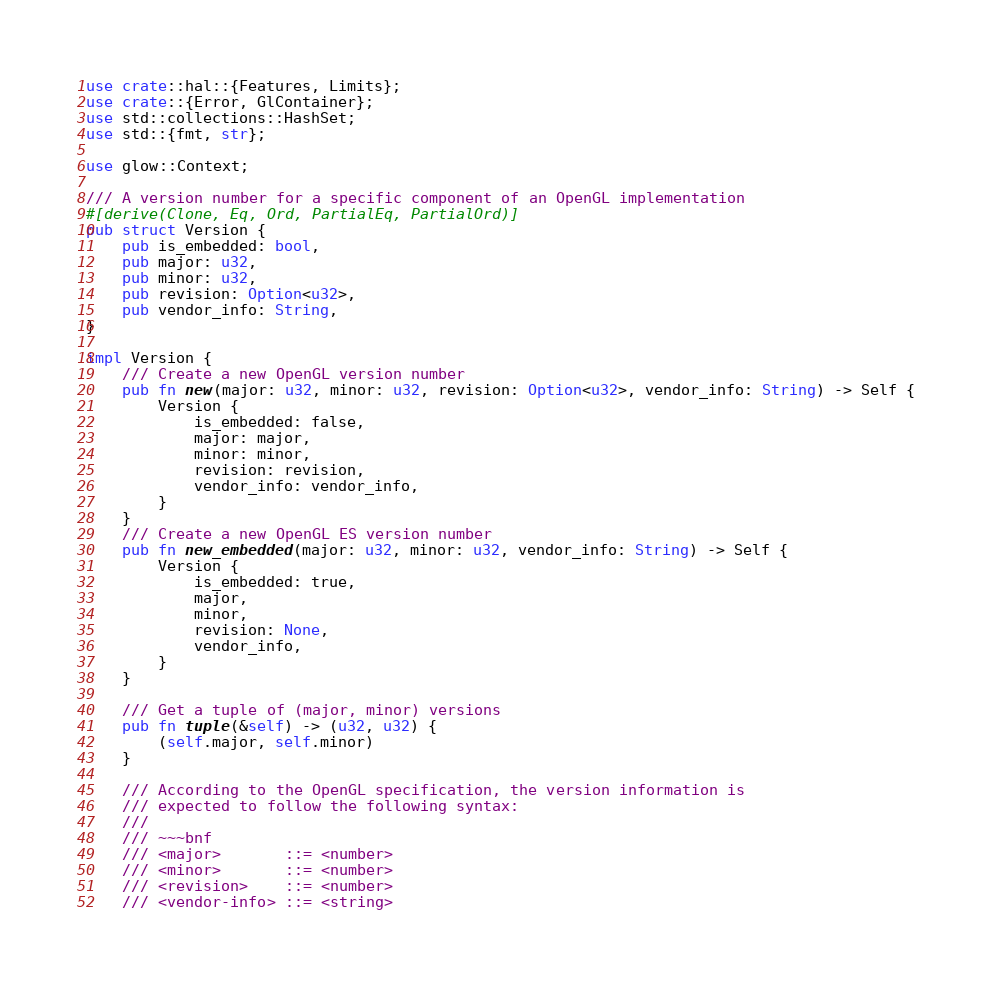Convert code to text. <code><loc_0><loc_0><loc_500><loc_500><_Rust_>use crate::hal::{Features, Limits};
use crate::{Error, GlContainer};
use std::collections::HashSet;
use std::{fmt, str};

use glow::Context;

/// A version number for a specific component of an OpenGL implementation
#[derive(Clone, Eq, Ord, PartialEq, PartialOrd)]
pub struct Version {
    pub is_embedded: bool,
    pub major: u32,
    pub minor: u32,
    pub revision: Option<u32>,
    pub vendor_info: String,
}

impl Version {
    /// Create a new OpenGL version number
    pub fn new(major: u32, minor: u32, revision: Option<u32>, vendor_info: String) -> Self {
        Version {
            is_embedded: false,
            major: major,
            minor: minor,
            revision: revision,
            vendor_info: vendor_info,
        }
    }
    /// Create a new OpenGL ES version number
    pub fn new_embedded(major: u32, minor: u32, vendor_info: String) -> Self {
        Version {
            is_embedded: true,
            major,
            minor,
            revision: None,
            vendor_info,
        }
    }

    /// Get a tuple of (major, minor) versions
    pub fn tuple(&self) -> (u32, u32) {
        (self.major, self.minor)
    }

    /// According to the OpenGL specification, the version information is
    /// expected to follow the following syntax:
    ///
    /// ~~~bnf
    /// <major>       ::= <number>
    /// <minor>       ::= <number>
    /// <revision>    ::= <number>
    /// <vendor-info> ::= <string></code> 